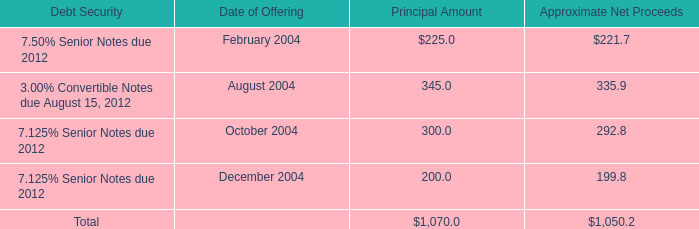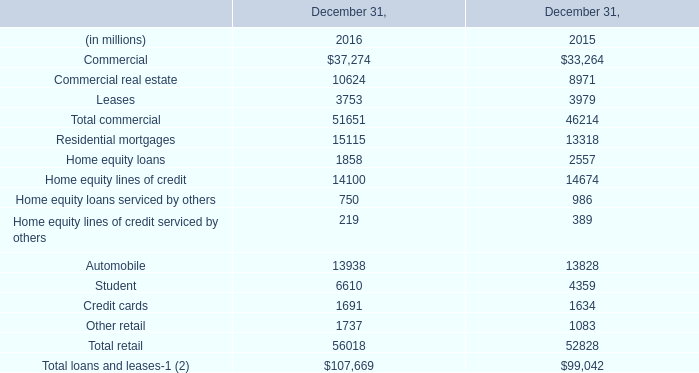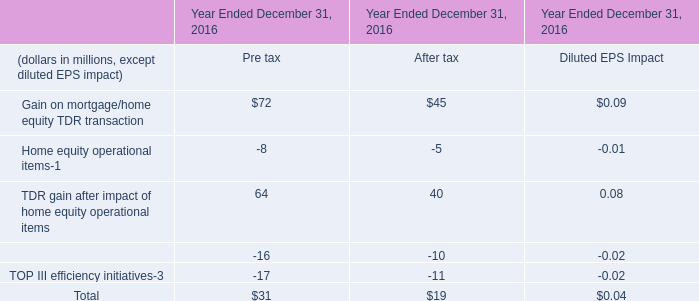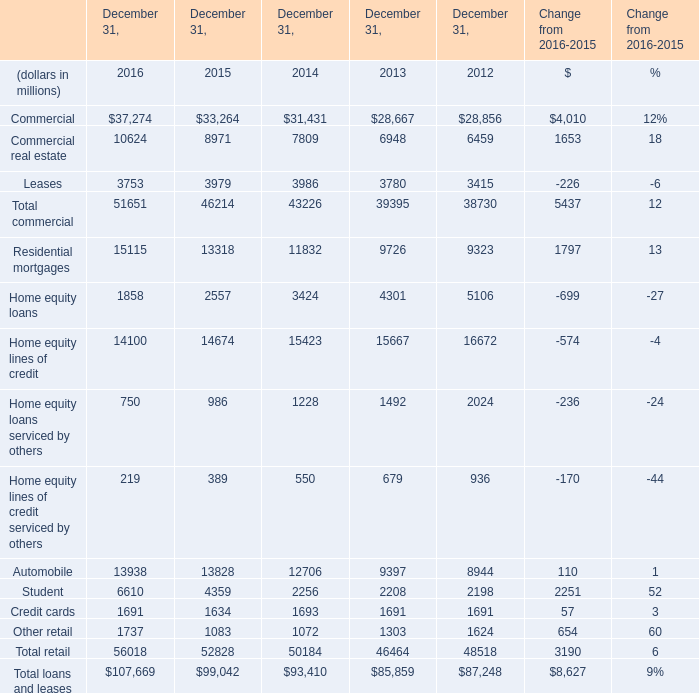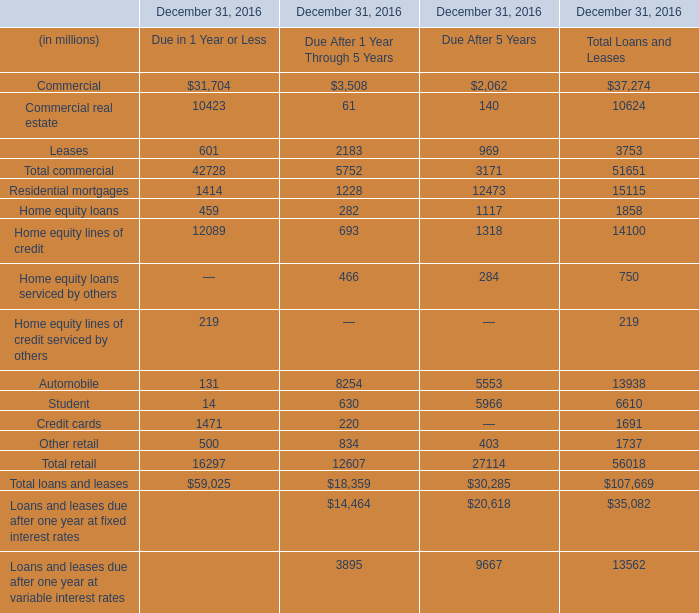What was the average of the Commercial Due in 1 Year or Less in the years where Commercial Due in 1 Year or Less is positive? (in millions) 
Answer: 31704. 